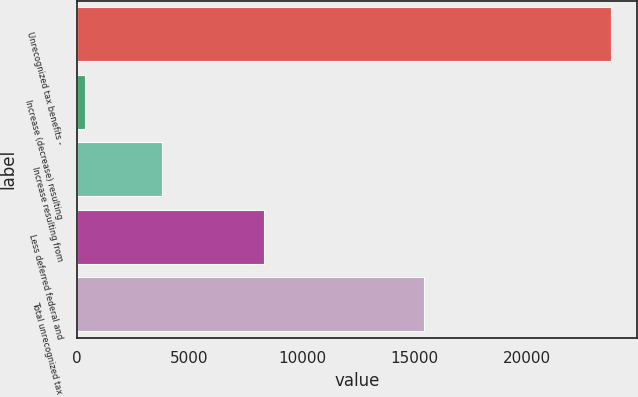<chart> <loc_0><loc_0><loc_500><loc_500><bar_chart><fcel>Unrecognized tax benefits -<fcel>Increase (decrease) resulting<fcel>Increase resulting from<fcel>Less deferred federal and<fcel>Total unrecognized tax<nl><fcel>23719<fcel>366<fcel>3787<fcel>8302<fcel>15417<nl></chart> 